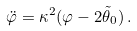<formula> <loc_0><loc_0><loc_500><loc_500>\ddot { \varphi } = \kappa ^ { 2 } ( \varphi - 2 \tilde { \theta } _ { 0 } ) \, .</formula> 